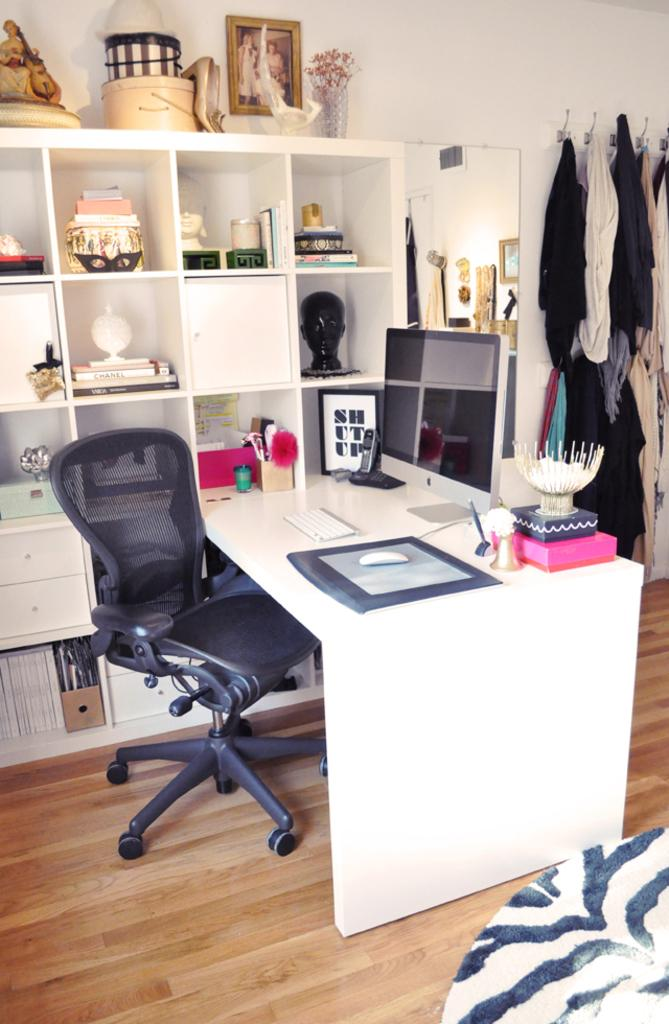Provide a one-sentence caption for the provided image. office desk with a framed picture that has "shut up"  next to monitor. 